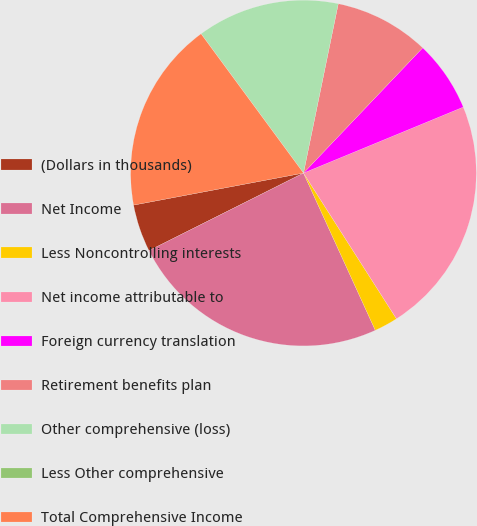<chart> <loc_0><loc_0><loc_500><loc_500><pie_chart><fcel>(Dollars in thousands)<fcel>Net Income<fcel>Less Noncontrolling interests<fcel>Net income attributable to<fcel>Foreign currency translation<fcel>Retirement benefits plan<fcel>Other comprehensive (loss)<fcel>Less Other comprehensive<fcel>Total Comprehensive Income<nl><fcel>4.44%<fcel>24.41%<fcel>2.22%<fcel>22.19%<fcel>6.66%<fcel>8.88%<fcel>13.32%<fcel>0.0%<fcel>17.87%<nl></chart> 